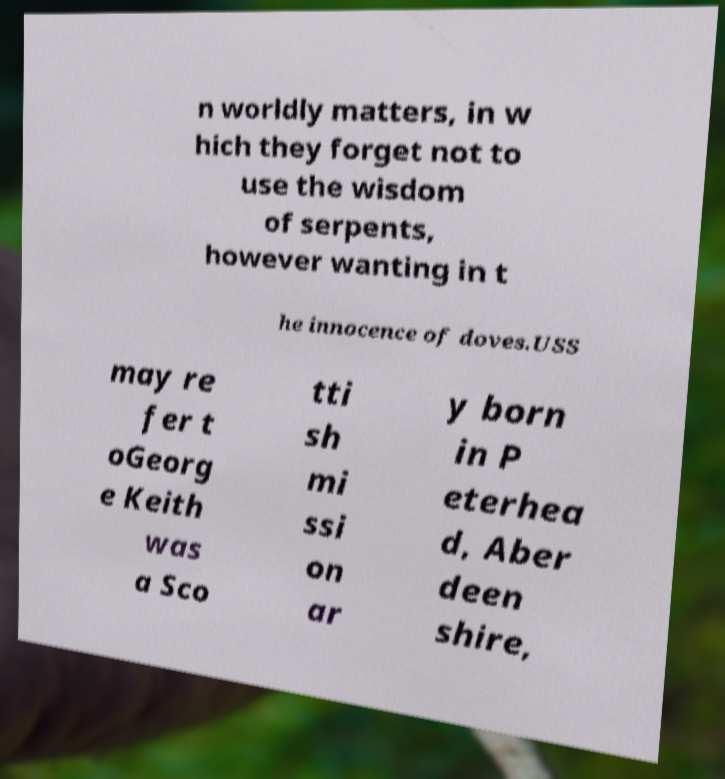There's text embedded in this image that I need extracted. Can you transcribe it verbatim? n worldly matters, in w hich they forget not to use the wisdom of serpents, however wanting in t he innocence of doves.USS may re fer t oGeorg e Keith was a Sco tti sh mi ssi on ar y born in P eterhea d, Aber deen shire, 